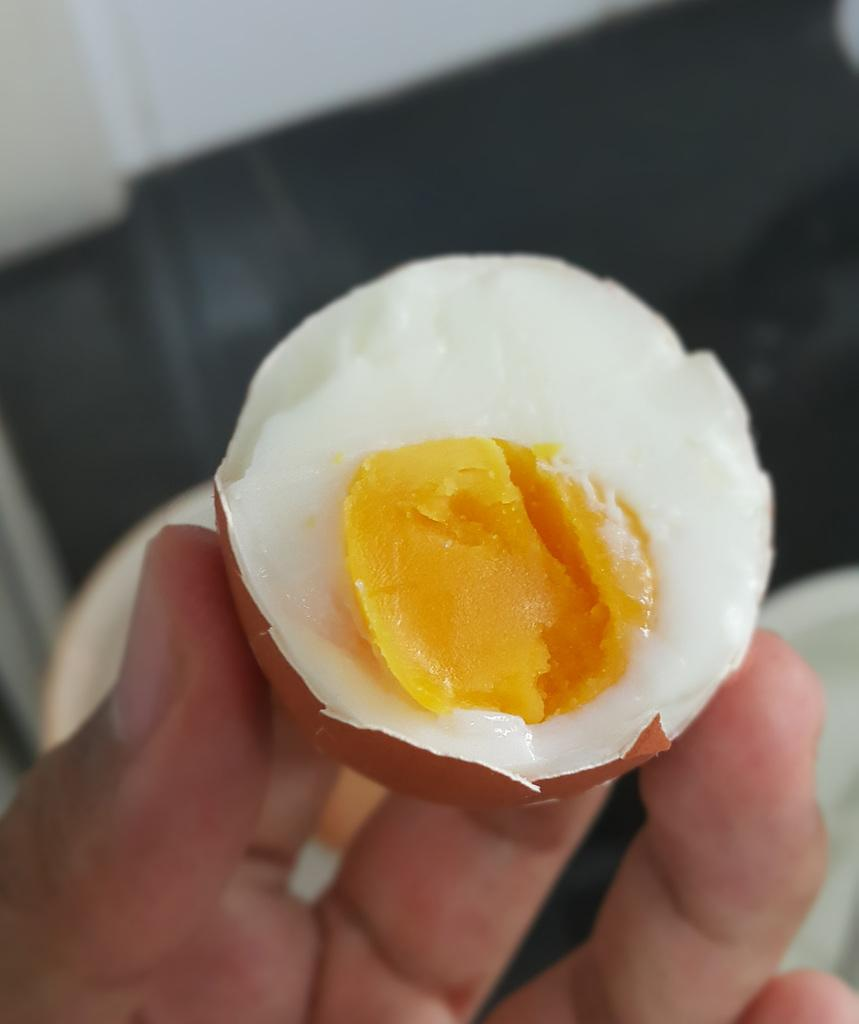What is the main object being held by a person in the image? There is a boiled egg in the image, and it is being held by a person. What can be seen in the background of the image? There is a wall visible in the image. What type of fight is taking place in the image? There is no fight present in the image; it features a person holding a boiled egg and a wall in the background. What is the level of wealth depicted in the image? The level of wealth cannot be determined from the image, as it only shows a person holding a boiled egg and a wall in the background. 